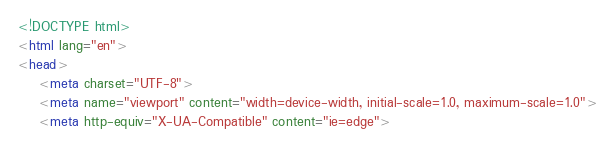<code> <loc_0><loc_0><loc_500><loc_500><_HTML_><!DOCTYPE html>
<html lang="en">
<head>
	<meta charset="UTF-8">
	<meta name="viewport" content="width=device-width, initial-scale=1.0, maximum-scale=1.0">
	<meta http-equiv="X-UA-Compatible" content="ie=edge"></code> 